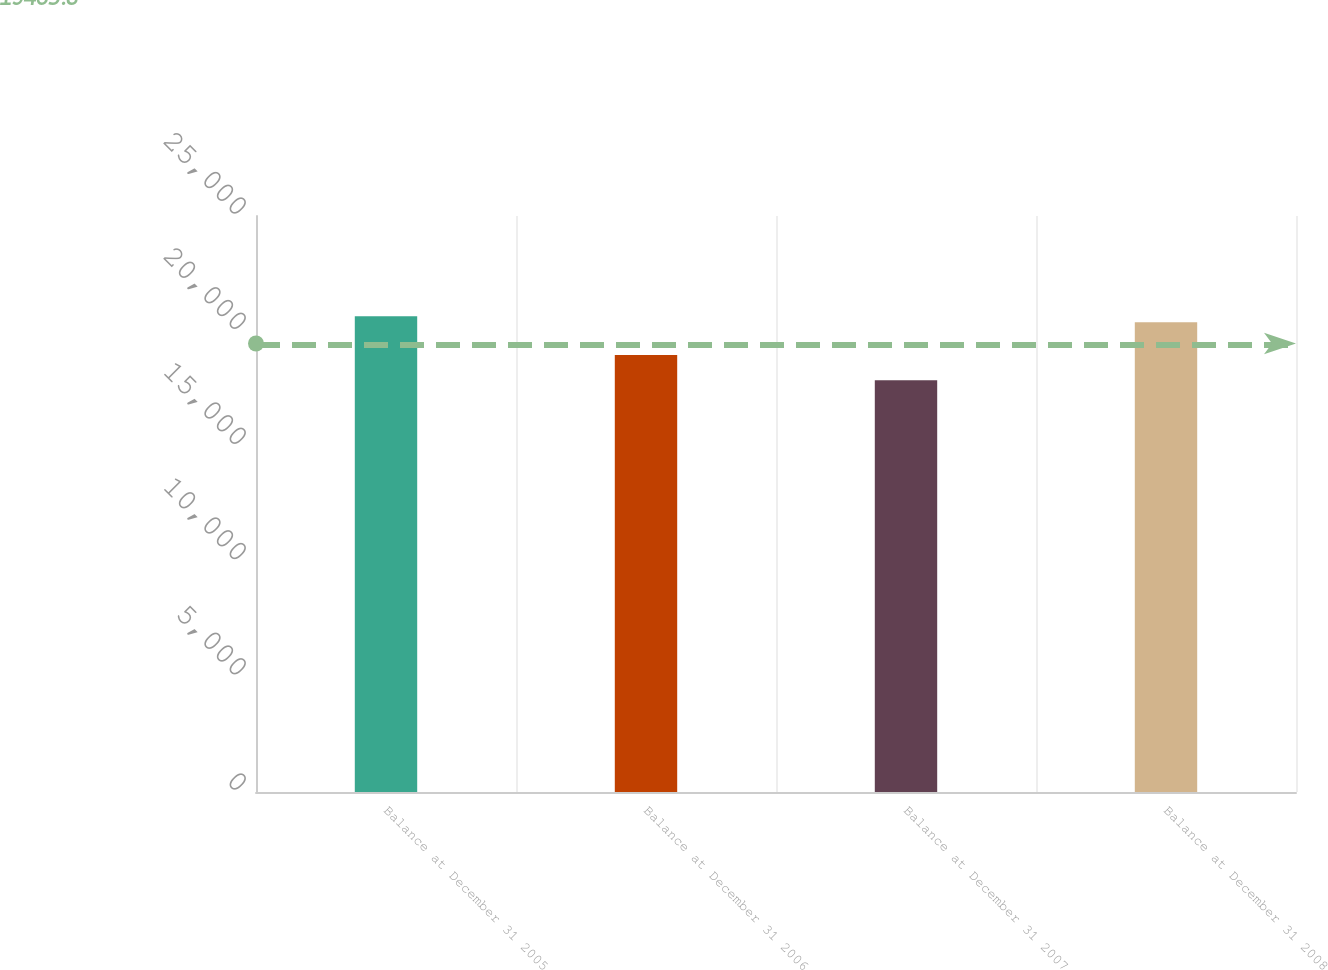<chart> <loc_0><loc_0><loc_500><loc_500><bar_chart><fcel>Balance at December 31 2005<fcel>Balance at December 31 2006<fcel>Balance at December 31 2007<fcel>Balance at December 31 2008<nl><fcel>20644.2<fcel>18964<fcel>17869<fcel>20386<nl></chart> 